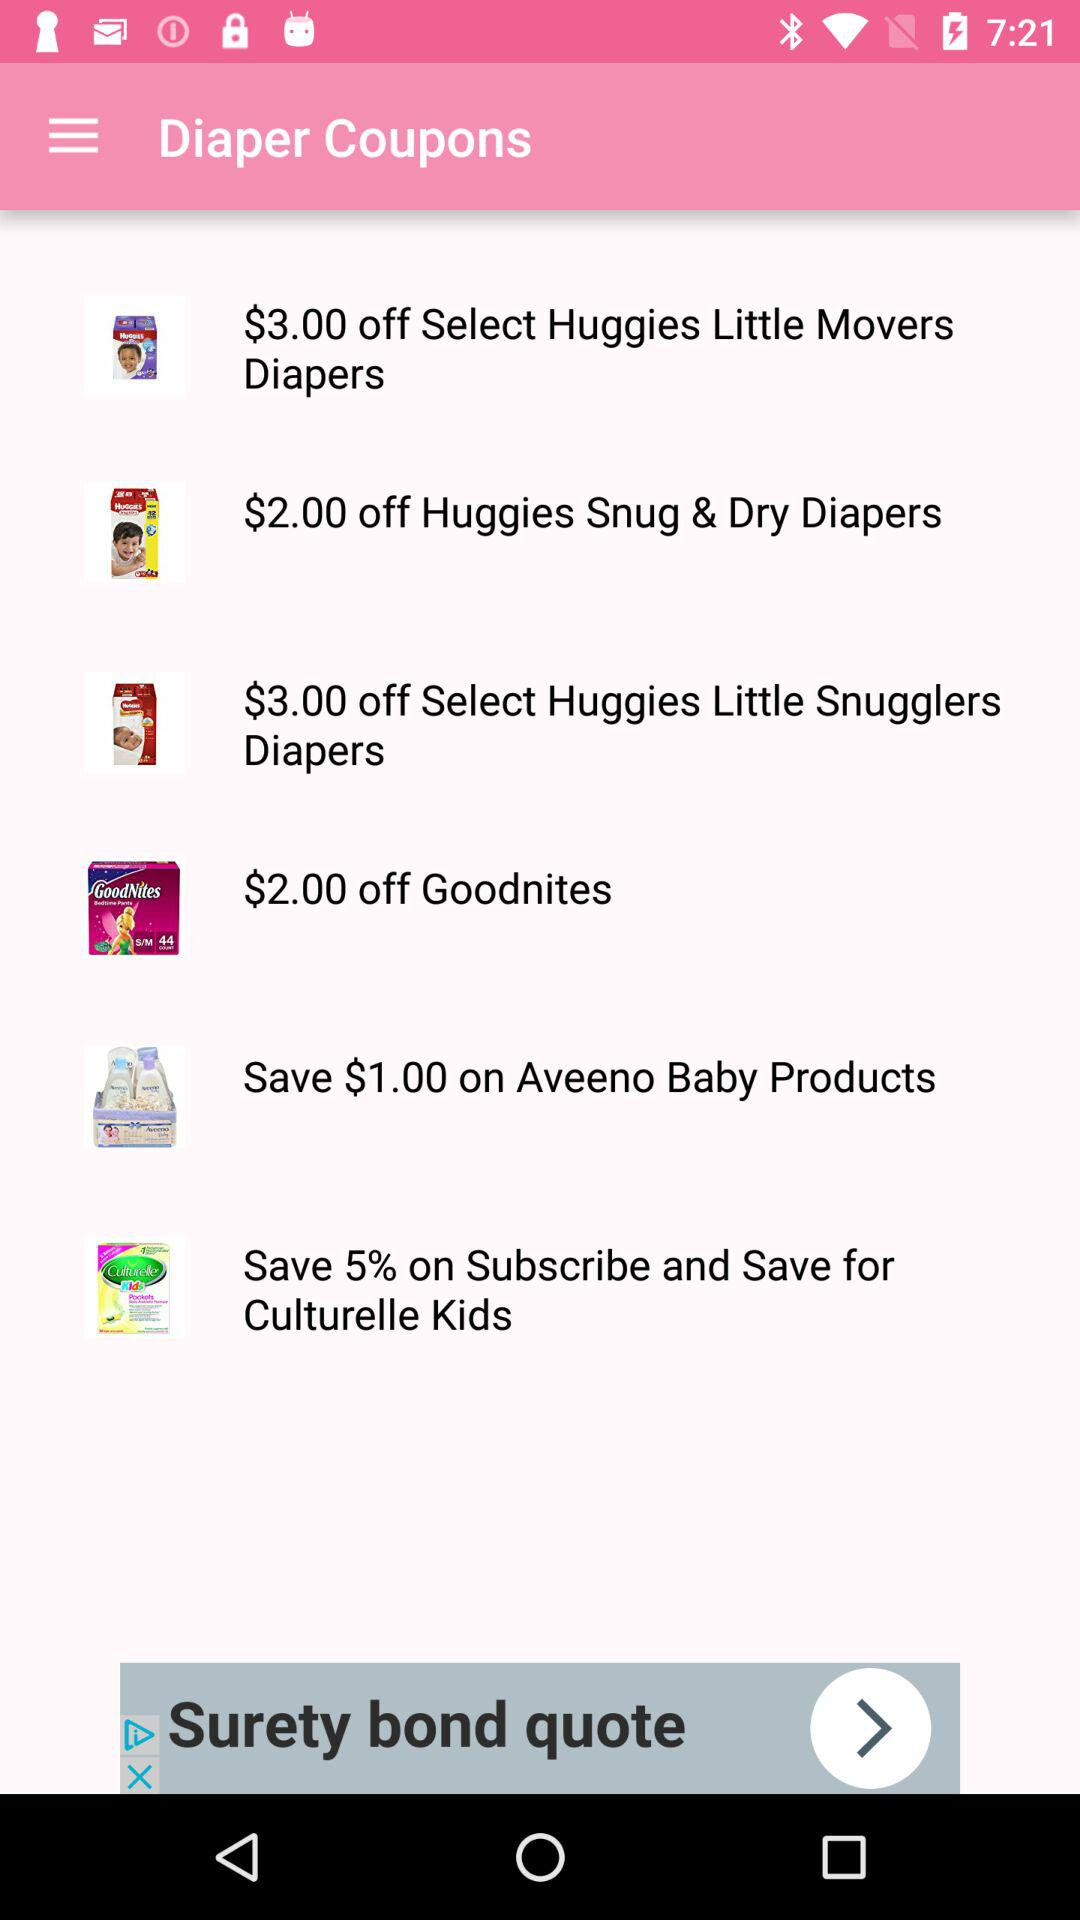What amount can be saved on "Aveeno Baby Products"? The amount that can be saved on "Aveeno Baby Products" is $1. 